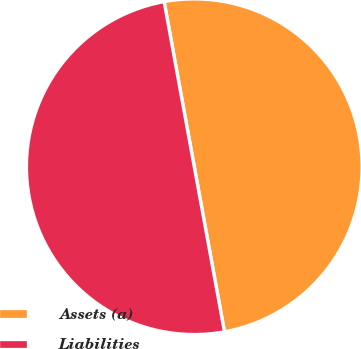<chart> <loc_0><loc_0><loc_500><loc_500><pie_chart><fcel>Assets (a)<fcel>Liabilities<nl><fcel>49.99%<fcel>50.01%<nl></chart> 